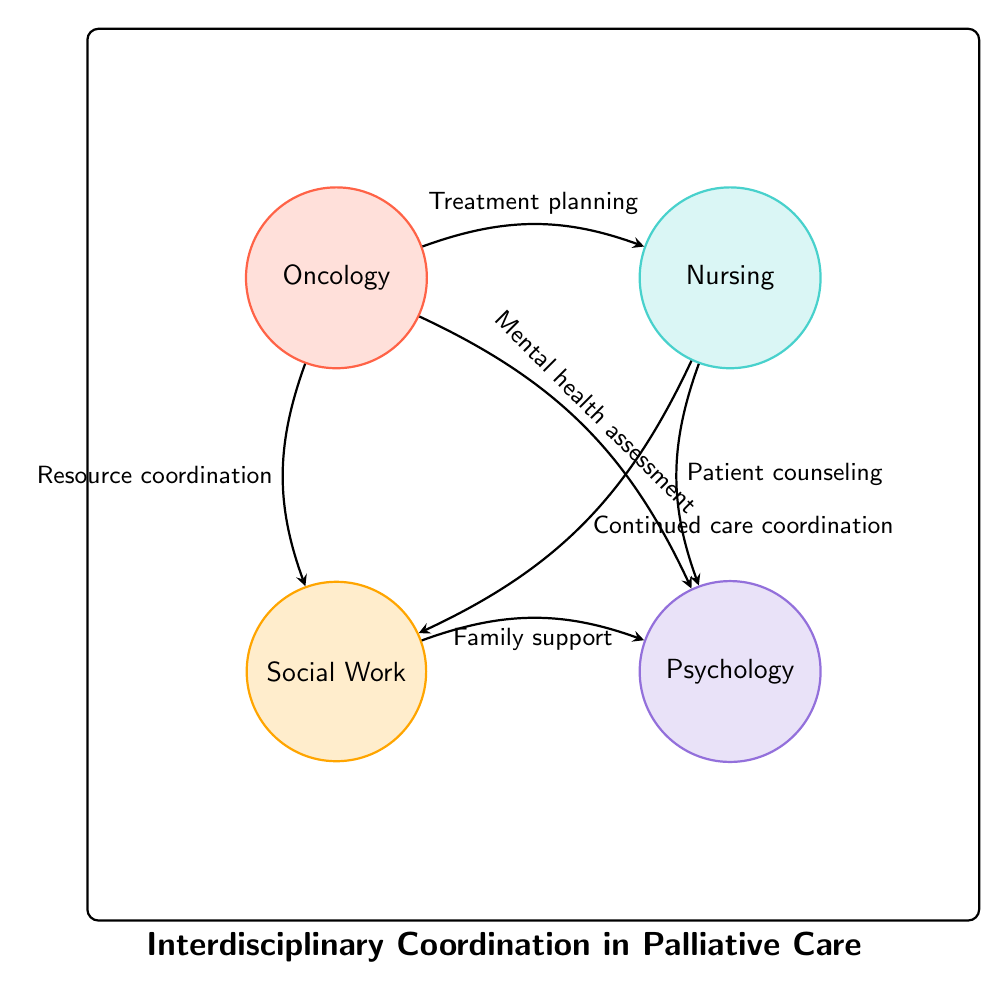What are the nodes in the diagram? The diagram contains four nodes: Oncology, Nursing, Social Work, and Psychology. This information can be found by reading the node labels directly.
Answer: Oncology, Nursing, Social Work, Psychology How many links are there in the diagram? The diagram includes six distinct links connecting the nodes. This can be determined by counting each link that appears in the connections between the nodes.
Answer: 6 What interaction is between Oncology and Nursing? The link between Oncology and Nursing indicates "Treatment planning" as the interaction. This can be seen from the arrow connecting these two nodes, which is labeled with this interaction.
Answer: Treatment planning Which node has the most interactions? The node 'Oncology' has three interactions with Nursing, Social Work, and Psychology. This is determined by counting the outgoing links from each node and comparing the totals.
Answer: Oncology What does the interaction between Social Work and Psychology signify? The connection between Social Work and Psychology represents "Family support." This is identified by looking at the specified link that connects these two nodes and noting the label attributed to it.
Answer: Family support Which two disciplines coordinate for continued care? The disciplines involved in continued care coordination are Nursing and Social Work, as indicated by the specific link between them marked with that interaction.
Answer: Nursing, Social Work How many interactions does Nursing have in total? Nursing has two interactions: one with Oncology for treatment planning and one with Psychology for patient counseling. This can be ascertained by checking all the outbound links from the Nursing node.
Answer: 2 Which disciplines are involved in mental health assessment? The disciplines involved in mental health assessment are Oncology and Psychology. The interaction labeled as "Mental health assessment" connects these two nodes.
Answer: Oncology, Psychology What is the weakest link in terms of interaction value? Each link has a value of 1, indicating they all have equal strength or importance in interactions. Since all links are the same, it is not possible to identify one as weaker than the others.
Answer: All equal 